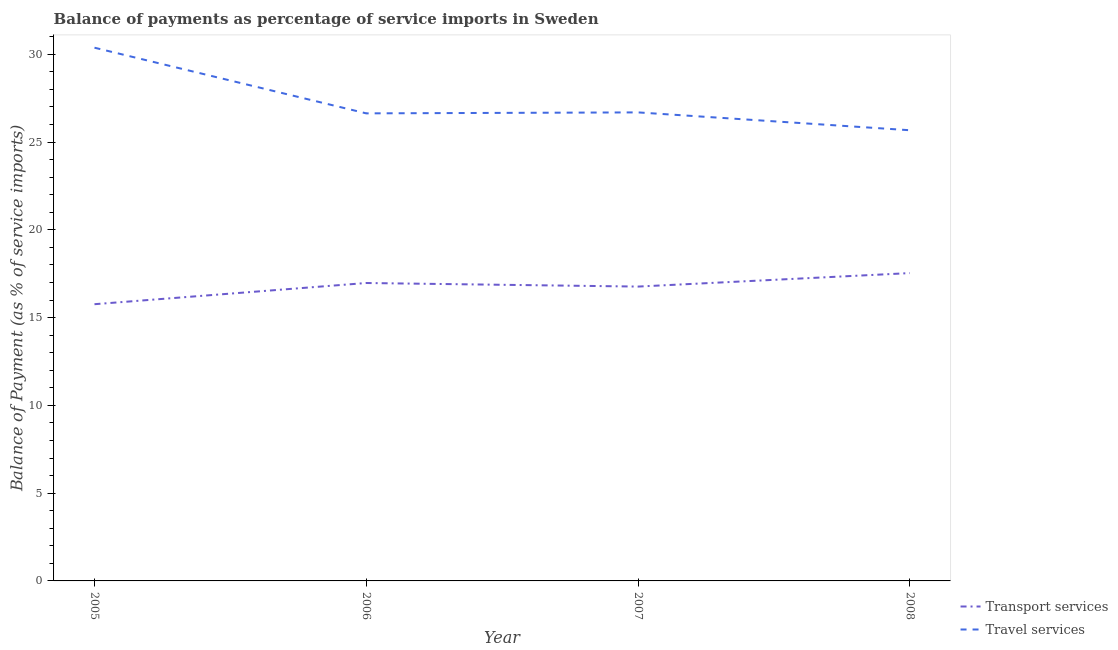What is the balance of payments of travel services in 2006?
Your response must be concise. 26.63. Across all years, what is the maximum balance of payments of transport services?
Make the answer very short. 17.54. Across all years, what is the minimum balance of payments of travel services?
Provide a succinct answer. 25.67. In which year was the balance of payments of travel services minimum?
Provide a succinct answer. 2008. What is the total balance of payments of transport services in the graph?
Provide a short and direct response. 67.03. What is the difference between the balance of payments of travel services in 2005 and that in 2006?
Offer a very short reply. 3.74. What is the difference between the balance of payments of transport services in 2007 and the balance of payments of travel services in 2008?
Ensure brevity in your answer.  -8.91. What is the average balance of payments of transport services per year?
Make the answer very short. 16.76. In the year 2006, what is the difference between the balance of payments of transport services and balance of payments of travel services?
Your answer should be very brief. -9.66. What is the ratio of the balance of payments of transport services in 2006 to that in 2008?
Provide a short and direct response. 0.97. Is the difference between the balance of payments of transport services in 2006 and 2007 greater than the difference between the balance of payments of travel services in 2006 and 2007?
Offer a terse response. Yes. What is the difference between the highest and the second highest balance of payments of transport services?
Provide a short and direct response. 0.56. What is the difference between the highest and the lowest balance of payments of travel services?
Offer a very short reply. 4.7. In how many years, is the balance of payments of travel services greater than the average balance of payments of travel services taken over all years?
Your response must be concise. 1. Is the sum of the balance of payments of travel services in 2005 and 2008 greater than the maximum balance of payments of transport services across all years?
Provide a succinct answer. Yes. How many lines are there?
Offer a very short reply. 2. Does the graph contain any zero values?
Your answer should be compact. No. Where does the legend appear in the graph?
Your answer should be very brief. Bottom right. How many legend labels are there?
Provide a succinct answer. 2. How are the legend labels stacked?
Make the answer very short. Vertical. What is the title of the graph?
Provide a succinct answer. Balance of payments as percentage of service imports in Sweden. Does "Underweight" appear as one of the legend labels in the graph?
Provide a succinct answer. No. What is the label or title of the Y-axis?
Make the answer very short. Balance of Payment (as % of service imports). What is the Balance of Payment (as % of service imports) in Transport services in 2005?
Provide a short and direct response. 15.76. What is the Balance of Payment (as % of service imports) of Travel services in 2005?
Provide a short and direct response. 30.37. What is the Balance of Payment (as % of service imports) in Transport services in 2006?
Provide a succinct answer. 16.97. What is the Balance of Payment (as % of service imports) of Travel services in 2006?
Your answer should be compact. 26.63. What is the Balance of Payment (as % of service imports) of Transport services in 2007?
Your response must be concise. 16.77. What is the Balance of Payment (as % of service imports) in Travel services in 2007?
Offer a very short reply. 26.69. What is the Balance of Payment (as % of service imports) in Transport services in 2008?
Keep it short and to the point. 17.54. What is the Balance of Payment (as % of service imports) in Travel services in 2008?
Provide a short and direct response. 25.67. Across all years, what is the maximum Balance of Payment (as % of service imports) in Transport services?
Your answer should be compact. 17.54. Across all years, what is the maximum Balance of Payment (as % of service imports) of Travel services?
Your answer should be very brief. 30.37. Across all years, what is the minimum Balance of Payment (as % of service imports) of Transport services?
Give a very brief answer. 15.76. Across all years, what is the minimum Balance of Payment (as % of service imports) in Travel services?
Keep it short and to the point. 25.67. What is the total Balance of Payment (as % of service imports) of Transport services in the graph?
Ensure brevity in your answer.  67.03. What is the total Balance of Payment (as % of service imports) of Travel services in the graph?
Make the answer very short. 109.37. What is the difference between the Balance of Payment (as % of service imports) of Transport services in 2005 and that in 2006?
Provide a short and direct response. -1.21. What is the difference between the Balance of Payment (as % of service imports) in Travel services in 2005 and that in 2006?
Your response must be concise. 3.74. What is the difference between the Balance of Payment (as % of service imports) in Transport services in 2005 and that in 2007?
Your answer should be very brief. -1. What is the difference between the Balance of Payment (as % of service imports) of Travel services in 2005 and that in 2007?
Provide a short and direct response. 3.69. What is the difference between the Balance of Payment (as % of service imports) in Transport services in 2005 and that in 2008?
Ensure brevity in your answer.  -1.77. What is the difference between the Balance of Payment (as % of service imports) of Travel services in 2005 and that in 2008?
Offer a very short reply. 4.7. What is the difference between the Balance of Payment (as % of service imports) in Transport services in 2006 and that in 2007?
Your response must be concise. 0.2. What is the difference between the Balance of Payment (as % of service imports) in Travel services in 2006 and that in 2007?
Offer a very short reply. -0.06. What is the difference between the Balance of Payment (as % of service imports) in Transport services in 2006 and that in 2008?
Your answer should be very brief. -0.56. What is the difference between the Balance of Payment (as % of service imports) in Travel services in 2006 and that in 2008?
Give a very brief answer. 0.96. What is the difference between the Balance of Payment (as % of service imports) in Transport services in 2007 and that in 2008?
Ensure brevity in your answer.  -0.77. What is the difference between the Balance of Payment (as % of service imports) of Travel services in 2007 and that in 2008?
Make the answer very short. 1.02. What is the difference between the Balance of Payment (as % of service imports) in Transport services in 2005 and the Balance of Payment (as % of service imports) in Travel services in 2006?
Provide a succinct answer. -10.87. What is the difference between the Balance of Payment (as % of service imports) in Transport services in 2005 and the Balance of Payment (as % of service imports) in Travel services in 2007?
Ensure brevity in your answer.  -10.93. What is the difference between the Balance of Payment (as % of service imports) in Transport services in 2005 and the Balance of Payment (as % of service imports) in Travel services in 2008?
Keep it short and to the point. -9.91. What is the difference between the Balance of Payment (as % of service imports) of Transport services in 2006 and the Balance of Payment (as % of service imports) of Travel services in 2007?
Make the answer very short. -9.72. What is the difference between the Balance of Payment (as % of service imports) in Transport services in 2006 and the Balance of Payment (as % of service imports) in Travel services in 2008?
Offer a terse response. -8.7. What is the difference between the Balance of Payment (as % of service imports) of Transport services in 2007 and the Balance of Payment (as % of service imports) of Travel services in 2008?
Your answer should be very brief. -8.91. What is the average Balance of Payment (as % of service imports) in Transport services per year?
Make the answer very short. 16.76. What is the average Balance of Payment (as % of service imports) in Travel services per year?
Provide a short and direct response. 27.34. In the year 2005, what is the difference between the Balance of Payment (as % of service imports) in Transport services and Balance of Payment (as % of service imports) in Travel services?
Provide a succinct answer. -14.61. In the year 2006, what is the difference between the Balance of Payment (as % of service imports) in Transport services and Balance of Payment (as % of service imports) in Travel services?
Give a very brief answer. -9.66. In the year 2007, what is the difference between the Balance of Payment (as % of service imports) in Transport services and Balance of Payment (as % of service imports) in Travel services?
Give a very brief answer. -9.92. In the year 2008, what is the difference between the Balance of Payment (as % of service imports) of Transport services and Balance of Payment (as % of service imports) of Travel services?
Your answer should be compact. -8.14. What is the ratio of the Balance of Payment (as % of service imports) of Transport services in 2005 to that in 2006?
Your response must be concise. 0.93. What is the ratio of the Balance of Payment (as % of service imports) of Travel services in 2005 to that in 2006?
Make the answer very short. 1.14. What is the ratio of the Balance of Payment (as % of service imports) in Transport services in 2005 to that in 2007?
Give a very brief answer. 0.94. What is the ratio of the Balance of Payment (as % of service imports) in Travel services in 2005 to that in 2007?
Provide a short and direct response. 1.14. What is the ratio of the Balance of Payment (as % of service imports) in Transport services in 2005 to that in 2008?
Your answer should be very brief. 0.9. What is the ratio of the Balance of Payment (as % of service imports) in Travel services in 2005 to that in 2008?
Offer a terse response. 1.18. What is the ratio of the Balance of Payment (as % of service imports) in Transport services in 2006 to that in 2007?
Keep it short and to the point. 1.01. What is the ratio of the Balance of Payment (as % of service imports) in Transport services in 2006 to that in 2008?
Ensure brevity in your answer.  0.97. What is the ratio of the Balance of Payment (as % of service imports) in Travel services in 2006 to that in 2008?
Offer a very short reply. 1.04. What is the ratio of the Balance of Payment (as % of service imports) in Transport services in 2007 to that in 2008?
Your answer should be compact. 0.96. What is the ratio of the Balance of Payment (as % of service imports) in Travel services in 2007 to that in 2008?
Make the answer very short. 1.04. What is the difference between the highest and the second highest Balance of Payment (as % of service imports) of Transport services?
Provide a succinct answer. 0.56. What is the difference between the highest and the second highest Balance of Payment (as % of service imports) in Travel services?
Offer a terse response. 3.69. What is the difference between the highest and the lowest Balance of Payment (as % of service imports) in Transport services?
Provide a succinct answer. 1.77. What is the difference between the highest and the lowest Balance of Payment (as % of service imports) of Travel services?
Your answer should be very brief. 4.7. 